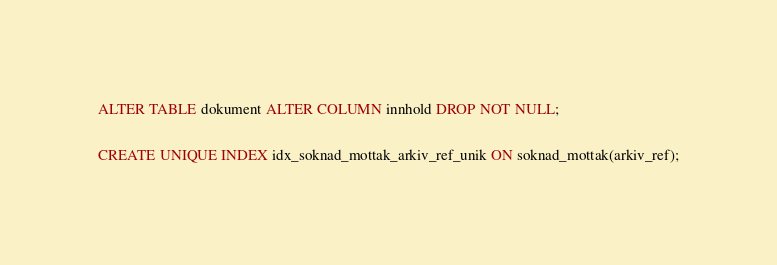Convert code to text. <code><loc_0><loc_0><loc_500><loc_500><_SQL_>ALTER TABLE dokument ALTER COLUMN innhold DROP NOT NULL;

CREATE UNIQUE INDEX idx_soknad_mottak_arkiv_ref_unik ON soknad_mottak(arkiv_ref);
</code> 